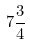<formula> <loc_0><loc_0><loc_500><loc_500>7 \frac { 3 } { 4 }</formula> 